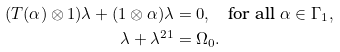Convert formula to latex. <formula><loc_0><loc_0><loc_500><loc_500>( T ( \alpha ) \otimes 1 ) \lambda + ( 1 \otimes \alpha ) \lambda & = 0 , \quad \text {for all } \alpha \in \Gamma _ { 1 } , \\ \lambda + \lambda ^ { 2 1 } & = \Omega _ { 0 } .</formula> 